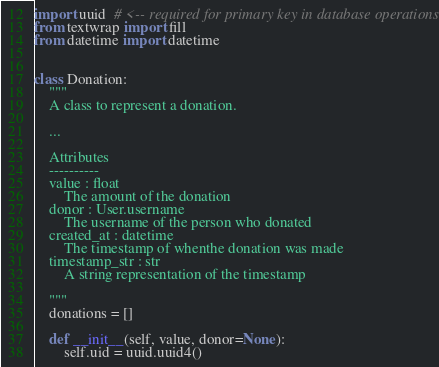Convert code to text. <code><loc_0><loc_0><loc_500><loc_500><_Python_>import uuid  # <-- required for primary key in database operations
from textwrap import fill
from datetime import datetime


class Donation:
    """
    A class to represent a donation.
    
    ...

    Attributes
    ----------
    value : float
        The amount of the donation
    donor : User.username
        The username of the person who donated
    created_at : datetime
        The timestamp of whenthe donation was made
    timestamp_str : str
        A string representation of the timestamp

    """
    donations = []

    def __init__(self, value, donor=None):
        self.uid = uuid.uuid4()</code> 